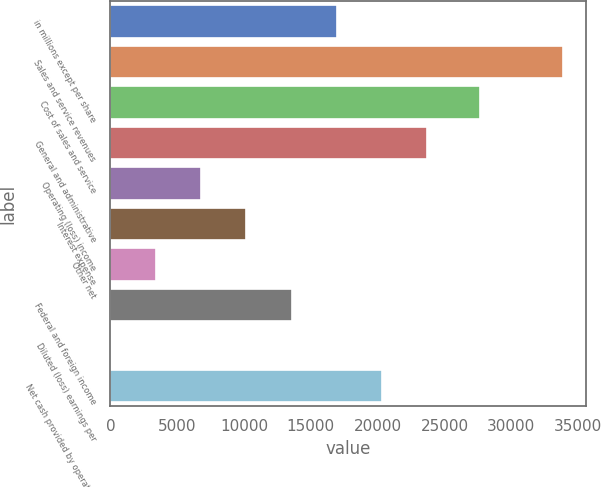<chart> <loc_0><loc_0><loc_500><loc_500><bar_chart><fcel>in millions except per share<fcel>Sales and service revenues<fcel>Cost of sales and service<fcel>General and administrative<fcel>Operating (loss) income<fcel>Interest expense<fcel>Other net<fcel>Federal and foreign income<fcel>Diluted (loss) earnings per<fcel>Net cash provided by operating<nl><fcel>16945.4<fcel>33887<fcel>27698<fcel>23722.1<fcel>6780.47<fcel>10168.8<fcel>3392.15<fcel>13557.1<fcel>3.83<fcel>20333.8<nl></chart> 